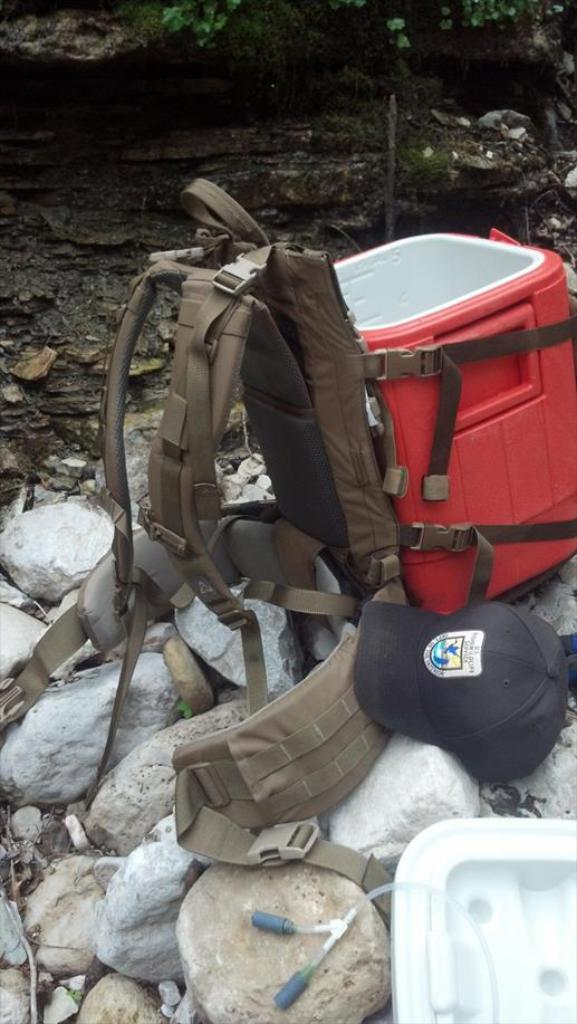How would you summarize this image in a sentence or two? The photo consists of a bag, red box, a cap, stones. 